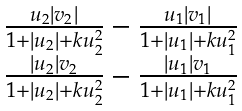Convert formula to latex. <formula><loc_0><loc_0><loc_500><loc_500>\begin{matrix} \frac { u _ { 2 } | v _ { 2 } | } { 1 + | u _ { 2 } | + k u _ { 2 } ^ { 2 } } - \frac { u _ { 1 } | v _ { 1 } | } { 1 + | u _ { 1 } | + k u _ { 1 } ^ { 2 } } \\ \frac { | u _ { 2 } | v _ { 2 } } { 1 + | u _ { 2 } | + k u _ { 2 } ^ { 2 } } - \frac { | u _ { 1 } | v _ { 1 } } { 1 + | u _ { 1 } | + k u _ { 1 } ^ { 2 } } \end{matrix}</formula> 